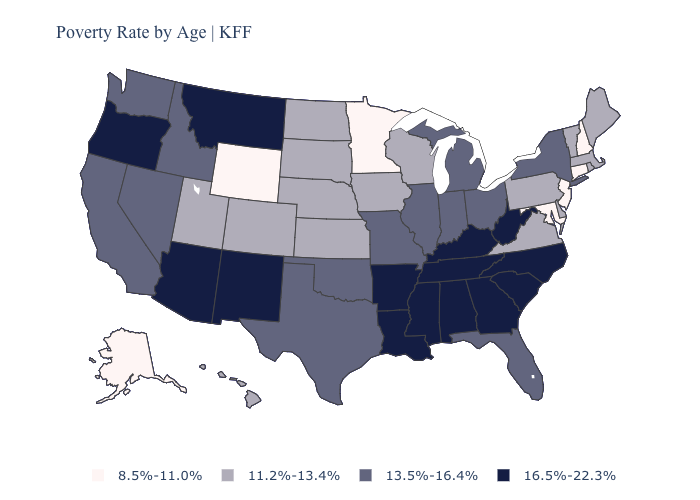Does North Carolina have the lowest value in the USA?
Give a very brief answer. No. What is the lowest value in the USA?
Answer briefly. 8.5%-11.0%. Name the states that have a value in the range 8.5%-11.0%?
Be succinct. Alaska, Connecticut, Maryland, Minnesota, New Hampshire, New Jersey, Wyoming. Among the states that border Kansas , does Nebraska have the lowest value?
Quick response, please. Yes. Name the states that have a value in the range 13.5%-16.4%?
Short answer required. California, Florida, Idaho, Illinois, Indiana, Michigan, Missouri, Nevada, New York, Ohio, Oklahoma, Texas, Washington. Name the states that have a value in the range 11.2%-13.4%?
Keep it brief. Colorado, Delaware, Hawaii, Iowa, Kansas, Maine, Massachusetts, Nebraska, North Dakota, Pennsylvania, Rhode Island, South Dakota, Utah, Vermont, Virginia, Wisconsin. What is the highest value in states that border Utah?
Write a very short answer. 16.5%-22.3%. Among the states that border Missouri , which have the highest value?
Concise answer only. Arkansas, Kentucky, Tennessee. Name the states that have a value in the range 16.5%-22.3%?
Be succinct. Alabama, Arizona, Arkansas, Georgia, Kentucky, Louisiana, Mississippi, Montana, New Mexico, North Carolina, Oregon, South Carolina, Tennessee, West Virginia. Which states have the highest value in the USA?
Be succinct. Alabama, Arizona, Arkansas, Georgia, Kentucky, Louisiana, Mississippi, Montana, New Mexico, North Carolina, Oregon, South Carolina, Tennessee, West Virginia. Does Maryland have the highest value in the South?
Keep it brief. No. Does the first symbol in the legend represent the smallest category?
Quick response, please. Yes. Name the states that have a value in the range 16.5%-22.3%?
Answer briefly. Alabama, Arizona, Arkansas, Georgia, Kentucky, Louisiana, Mississippi, Montana, New Mexico, North Carolina, Oregon, South Carolina, Tennessee, West Virginia. What is the value of Colorado?
Concise answer only. 11.2%-13.4%. What is the value of Montana?
Give a very brief answer. 16.5%-22.3%. 